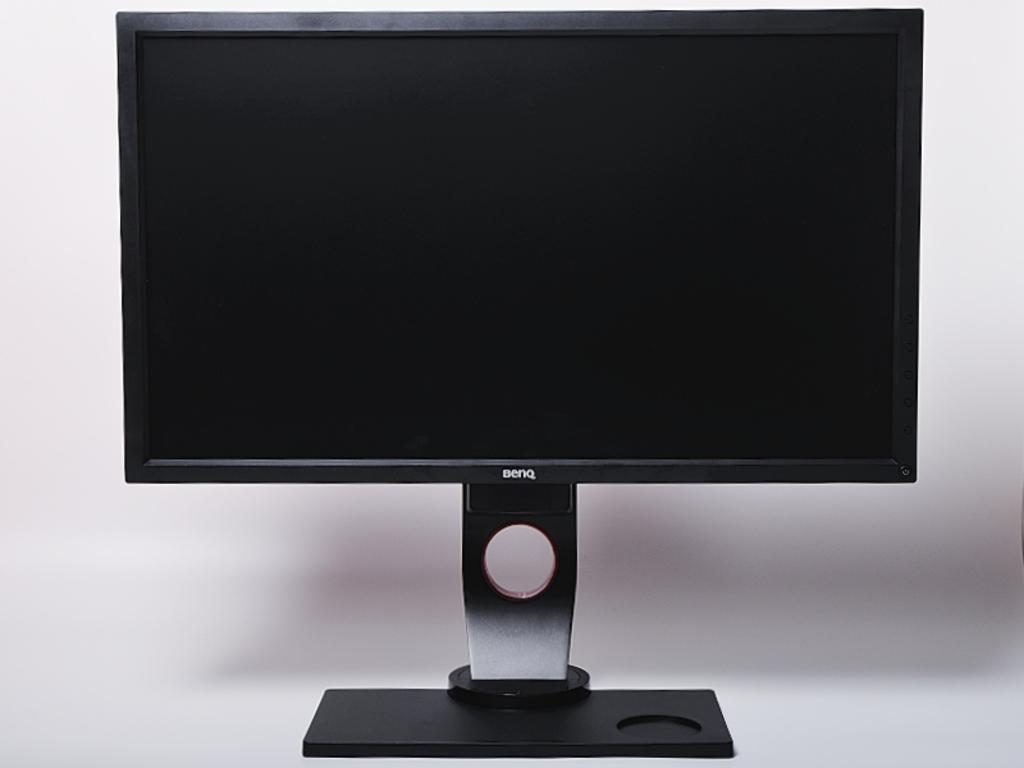<image>
Describe the image concisely. a Benq television that has a white background behind it 